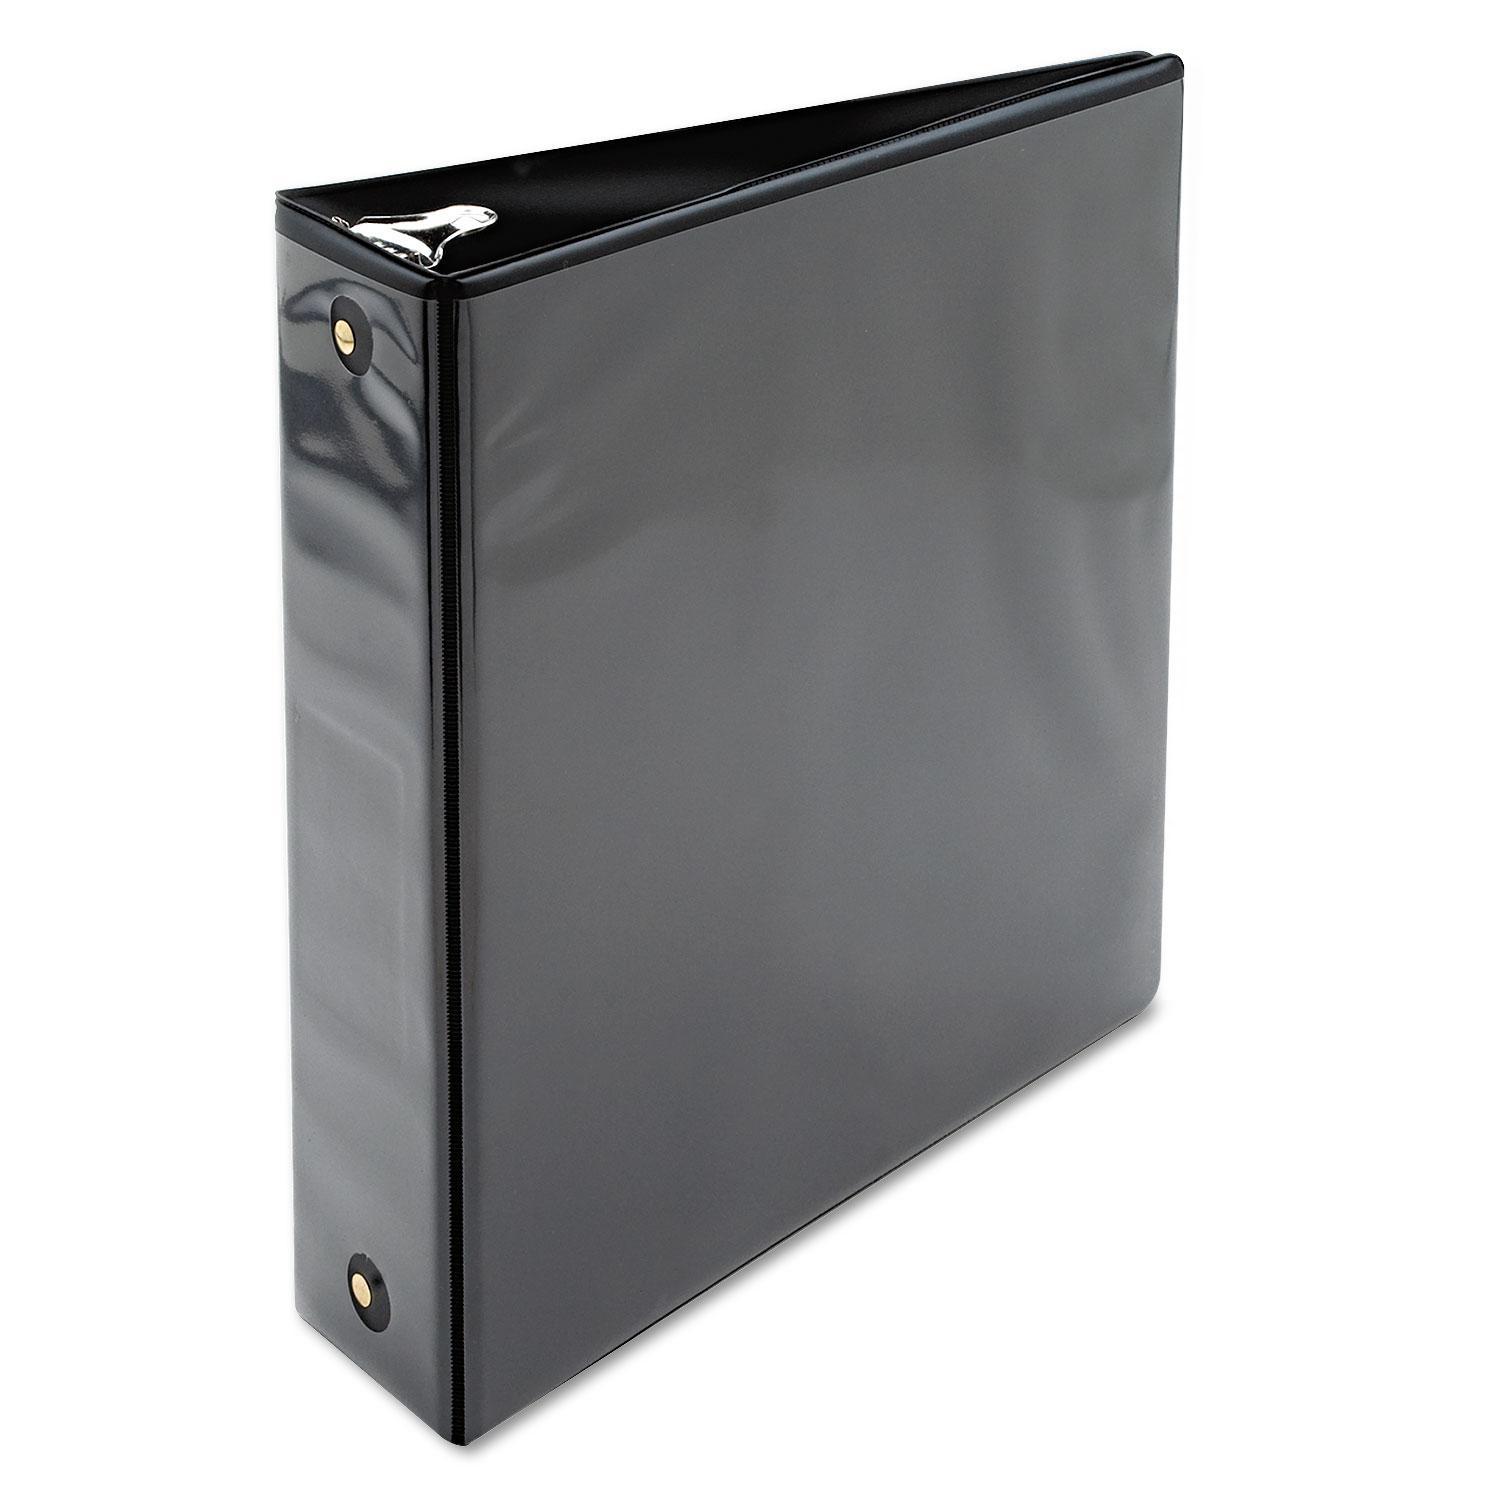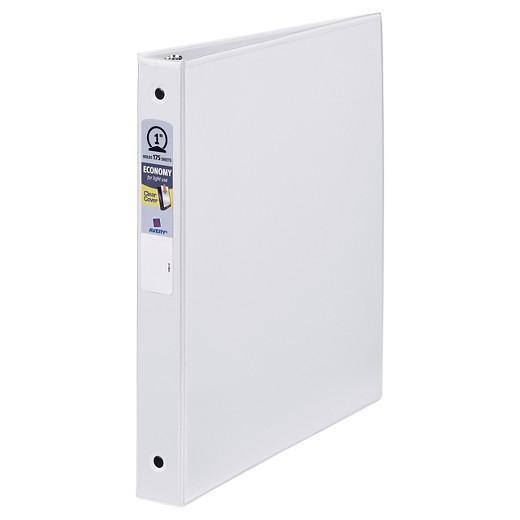The first image is the image on the left, the second image is the image on the right. Evaluate the accuracy of this statement regarding the images: "The right image contains exactly one white binder standing vertically.". Is it true? Answer yes or no. Yes. The first image is the image on the left, the second image is the image on the right. For the images shown, is this caption "There is a sticker on the spine of one of the binders." true? Answer yes or no. Yes. 